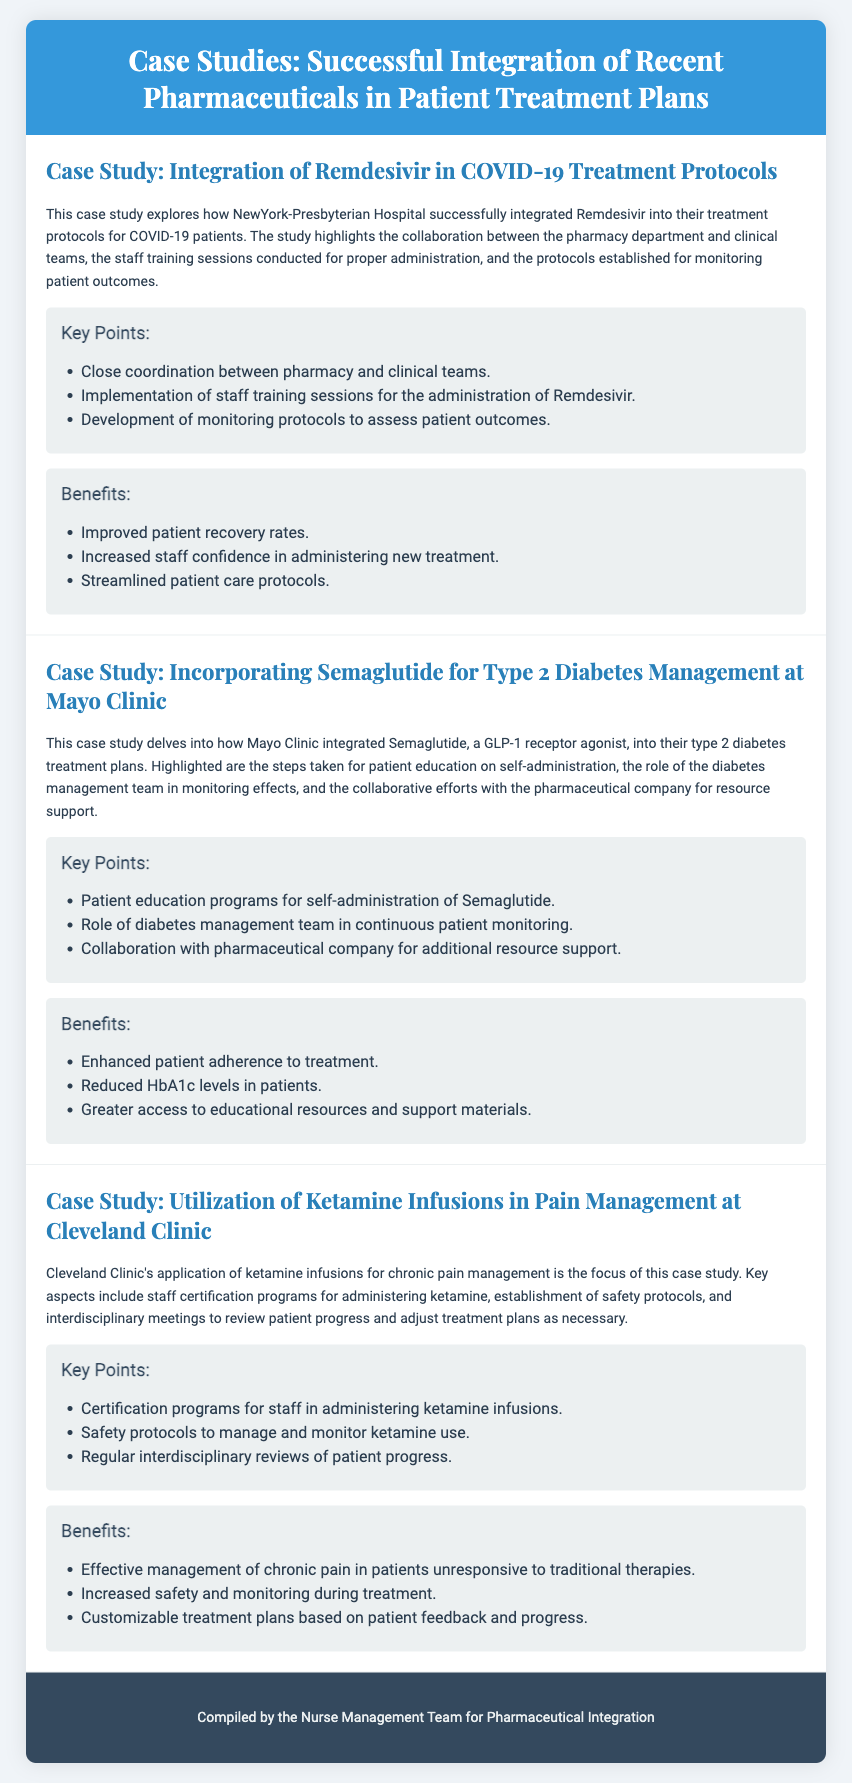What is the title of the first case study? The title of the first case study is found in the document's section that describes case studies, specifically mentioning "Integration of Remdesivir in COVID-19 Treatment Protocols."
Answer: Integration of Remdesivir in COVID-19 Treatment Protocols What is the primary focus of the second case study? The primary focus of the second case study is provided in the description, which states that it delves into how Mayo Clinic integrated Semaglutide into their type 2 diabetes treatment plans.
Answer: Incorporating Semaglutide for Type 2 Diabetes Management at Mayo Clinic How many key points are listed for the case study on Remdesivir? In the document, the section about key points for Remdesivir specifies three points related to the integration process.
Answer: 3 What type of treatment is highlighted in the third case study? The third case study focuses on a specific treatment method, as stated in the document, which is ketamine infusions for chronic pain management.
Answer: Ketamine infusions What is one benefit listed for the integration of Semaglutide? The document provides several benefits of Semaglutide integration, one of which mentions "Enhanced patient adherence to treatment."
Answer: Enhanced patient adherence to treatment Who compiled the document? The footer of the document attributes the compilation of the playbill to a specific team.
Answer: Nurse Management Team for Pharmaceutical Integration What hospital is associated with the first case study? The first case study mentions a particular hospital in its title, indicating where the integration took place.
Answer: NewYork-Presbyterian Hospital What role did the diabetes management team have in the integration of Semaglutide? The document specifies the role of the diabetes management team in monitoring effects as part of the integration process for Semaglutide.
Answer: Continuous patient monitoring What safety aspect was established in the case study on ketamine? In discussing the use of ketamine, the document notes a specific procedural development for safety management that is part of the integration approach.
Answer: Safety protocols 